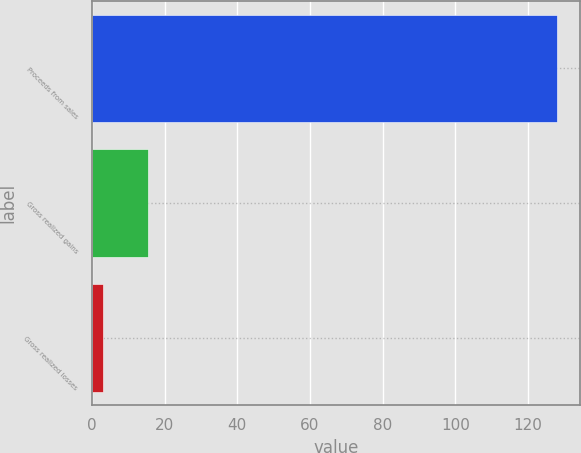Convert chart to OTSL. <chart><loc_0><loc_0><loc_500><loc_500><bar_chart><fcel>Proceeds from sales<fcel>Gross realized gains<fcel>Gross realized losses<nl><fcel>128<fcel>15.5<fcel>3<nl></chart> 